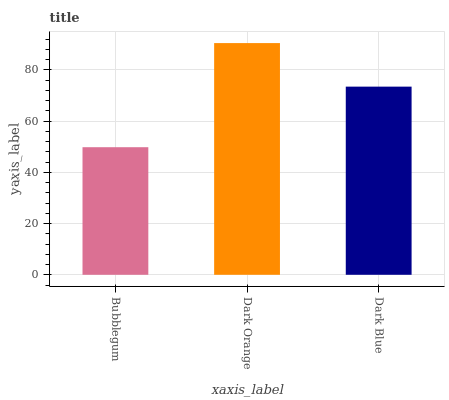Is Bubblegum the minimum?
Answer yes or no. Yes. Is Dark Orange the maximum?
Answer yes or no. Yes. Is Dark Blue the minimum?
Answer yes or no. No. Is Dark Blue the maximum?
Answer yes or no. No. Is Dark Orange greater than Dark Blue?
Answer yes or no. Yes. Is Dark Blue less than Dark Orange?
Answer yes or no. Yes. Is Dark Blue greater than Dark Orange?
Answer yes or no. No. Is Dark Orange less than Dark Blue?
Answer yes or no. No. Is Dark Blue the high median?
Answer yes or no. Yes. Is Dark Blue the low median?
Answer yes or no. Yes. Is Dark Orange the high median?
Answer yes or no. No. Is Bubblegum the low median?
Answer yes or no. No. 